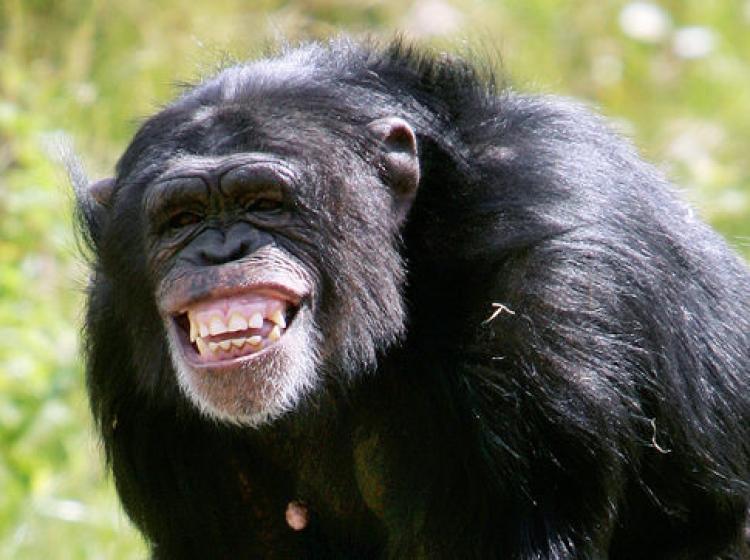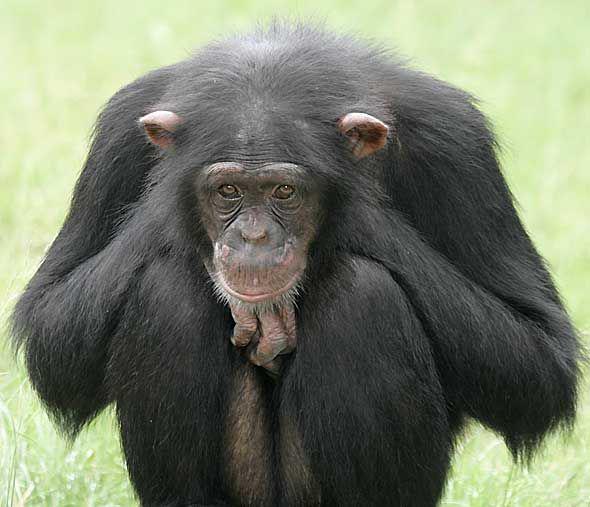The first image is the image on the left, the second image is the image on the right. Examine the images to the left and right. Is the description "The chimp in the right image is showing his teeth." accurate? Answer yes or no. No. 